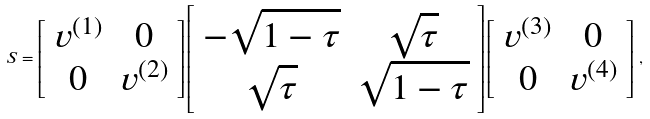Convert formula to latex. <formula><loc_0><loc_0><loc_500><loc_500>S = \left [ \begin{array} { c c } v ^ { ( 1 ) } & 0 \\ 0 & v ^ { ( 2 ) } \end{array} \right ] \left [ \begin{array} { c c } - \sqrt { 1 - \tau } & \sqrt { \tau } \\ \sqrt { \tau } & \sqrt { 1 - \tau } \end{array} \right ] \left [ \begin{array} { c c } v ^ { ( 3 ) } & 0 \\ 0 & v ^ { ( 4 ) } \end{array} \right ] \, ,</formula> 